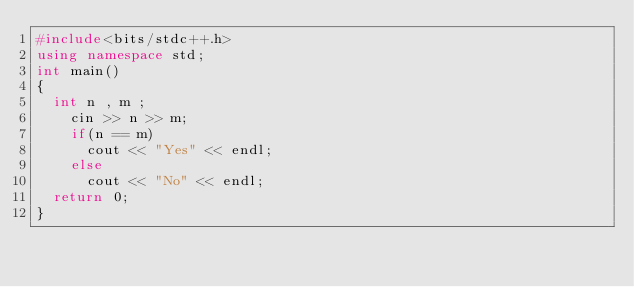<code> <loc_0><loc_0><loc_500><loc_500><_C++_>#include<bits/stdc++.h>
using namespace std;
int main()
{
	int n , m ;
  	cin >> n >> m;
  	if(n == m)
      cout << "Yes" << endl;
  	else
      cout << "No" << endl;
 	return 0; 
}</code> 